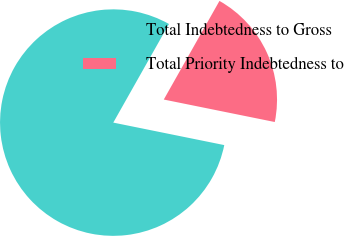<chart> <loc_0><loc_0><loc_500><loc_500><pie_chart><fcel>Total Indebtedness to Gross<fcel>Total Priority Indebtedness to<nl><fcel>80.0%<fcel>20.0%<nl></chart> 